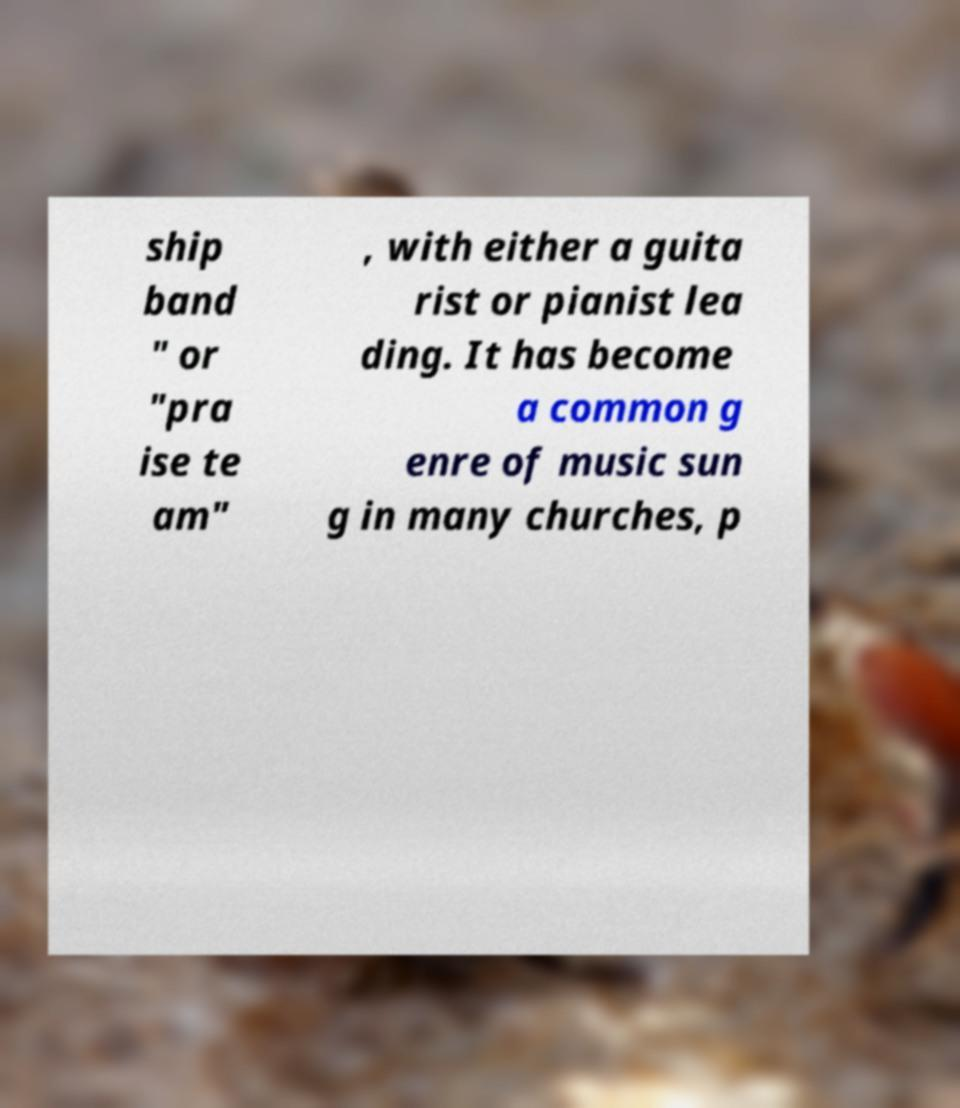For documentation purposes, I need the text within this image transcribed. Could you provide that? ship band " or "pra ise te am" , with either a guita rist or pianist lea ding. It has become a common g enre of music sun g in many churches, p 